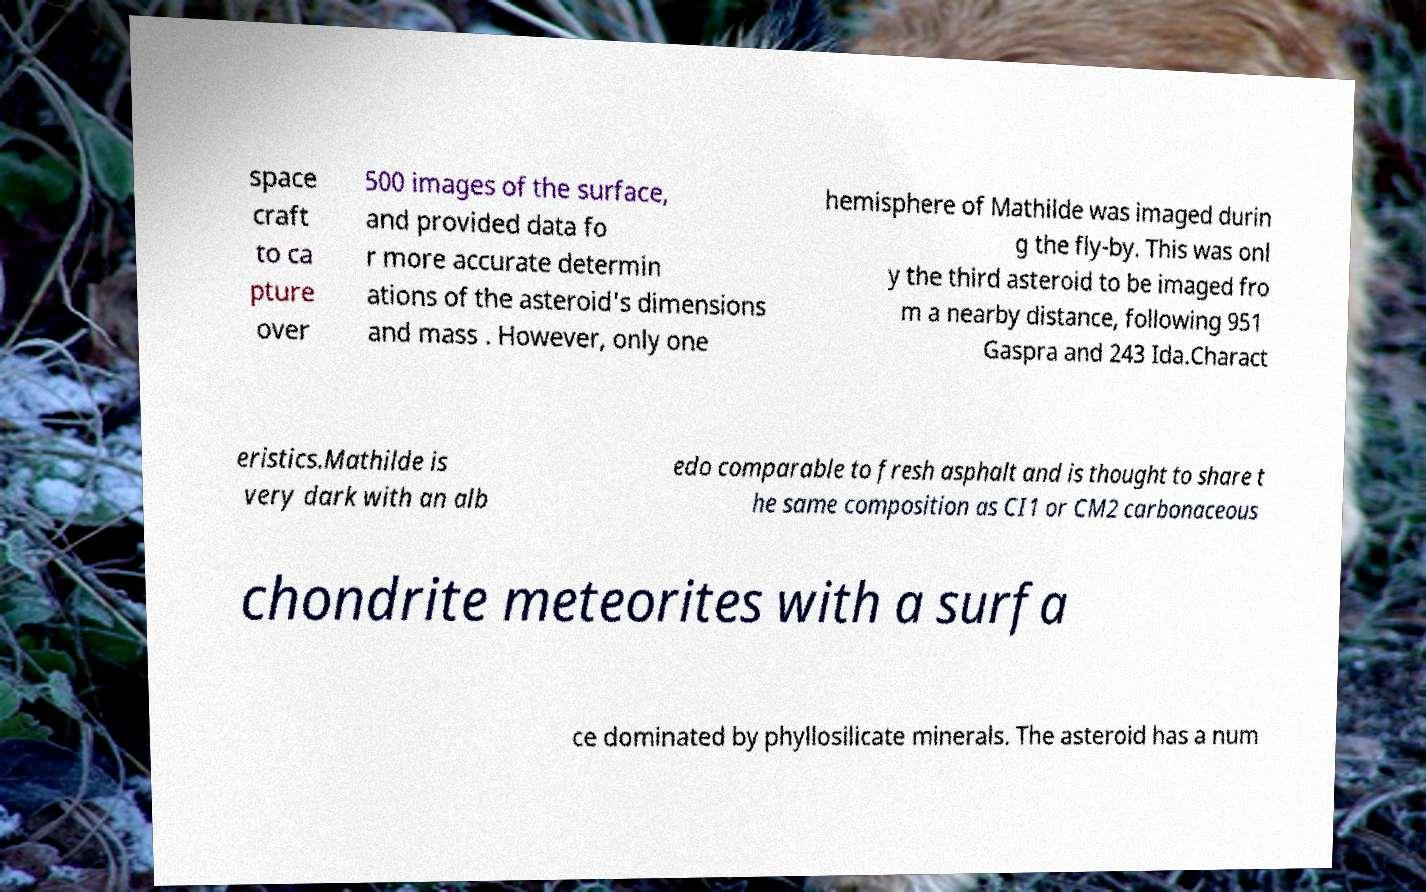Can you read and provide the text displayed in the image?This photo seems to have some interesting text. Can you extract and type it out for me? space craft to ca pture over 500 images of the surface, and provided data fo r more accurate determin ations of the asteroid's dimensions and mass . However, only one hemisphere of Mathilde was imaged durin g the fly-by. This was onl y the third asteroid to be imaged fro m a nearby distance, following 951 Gaspra and 243 Ida.Charact eristics.Mathilde is very dark with an alb edo comparable to fresh asphalt and is thought to share t he same composition as CI1 or CM2 carbonaceous chondrite meteorites with a surfa ce dominated by phyllosilicate minerals. The asteroid has a num 